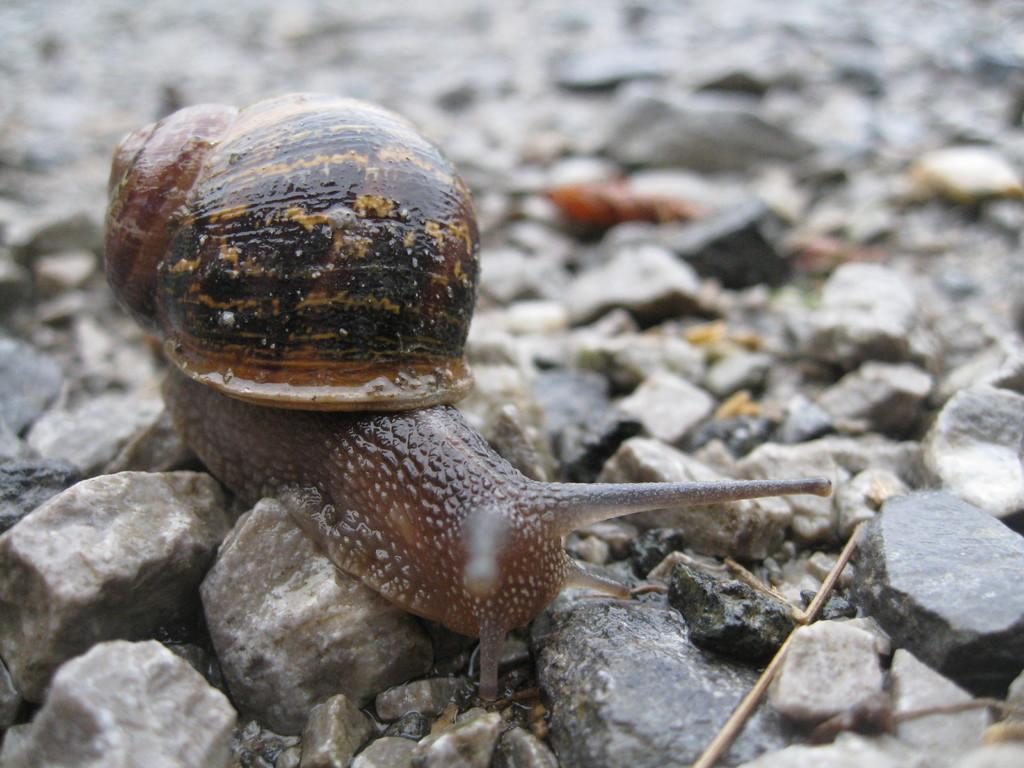What is the main subject of the image? The main subject of the image is a group of children playing with a ball. What is the setting of the image? The setting of the image is a park. What can be seen in the background of the image? There are trees and a playground in the background of the image. What type of spot can be seen on the book in the image? There is no book present in the image; it features a group of children playing with a ball in a park. 